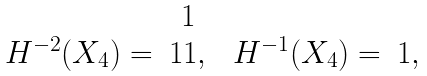<formula> <loc_0><loc_0><loc_500><loc_500>\begin{array} { c c } & 1 \\ H ^ { - 2 } ( X _ { 4 } ) = & 1 1 , \\ \end{array} \ \begin{array} { c c } & \\ H ^ { - 1 } ( X _ { 4 } ) = & 1 , \\ \end{array}</formula> 